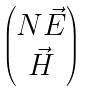<formula> <loc_0><loc_0><loc_500><loc_500>\begin{pmatrix} N \vec { E } \\ \vec { H } \end{pmatrix}</formula> 